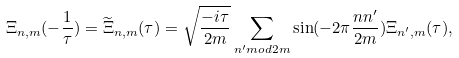Convert formula to latex. <formula><loc_0><loc_0><loc_500><loc_500>\Xi _ { n , m } ( - \frac { 1 } { \tau } ) = \widetilde { \Xi } _ { n , m } ( \tau ) = \sqrt { \frac { - i \tau } { 2 m } } \sum _ { n ^ { \prime } m o d 2 m } \sin ( - 2 \pi \frac { n n ^ { \prime } } { 2 m } ) \Xi _ { n ^ { \prime } , m } ( \tau ) ,</formula> 